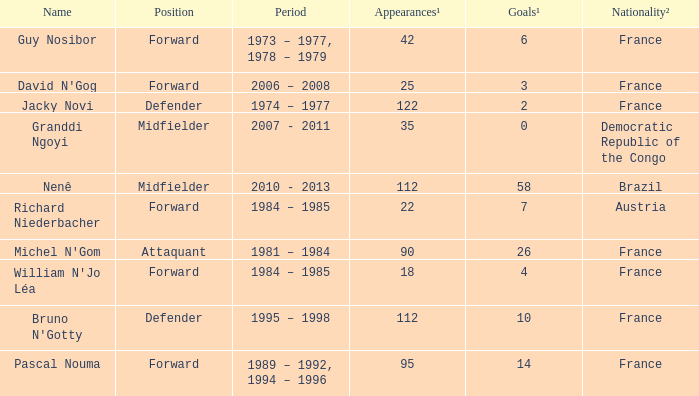List the number of active years for attaquant. 1981 – 1984. 